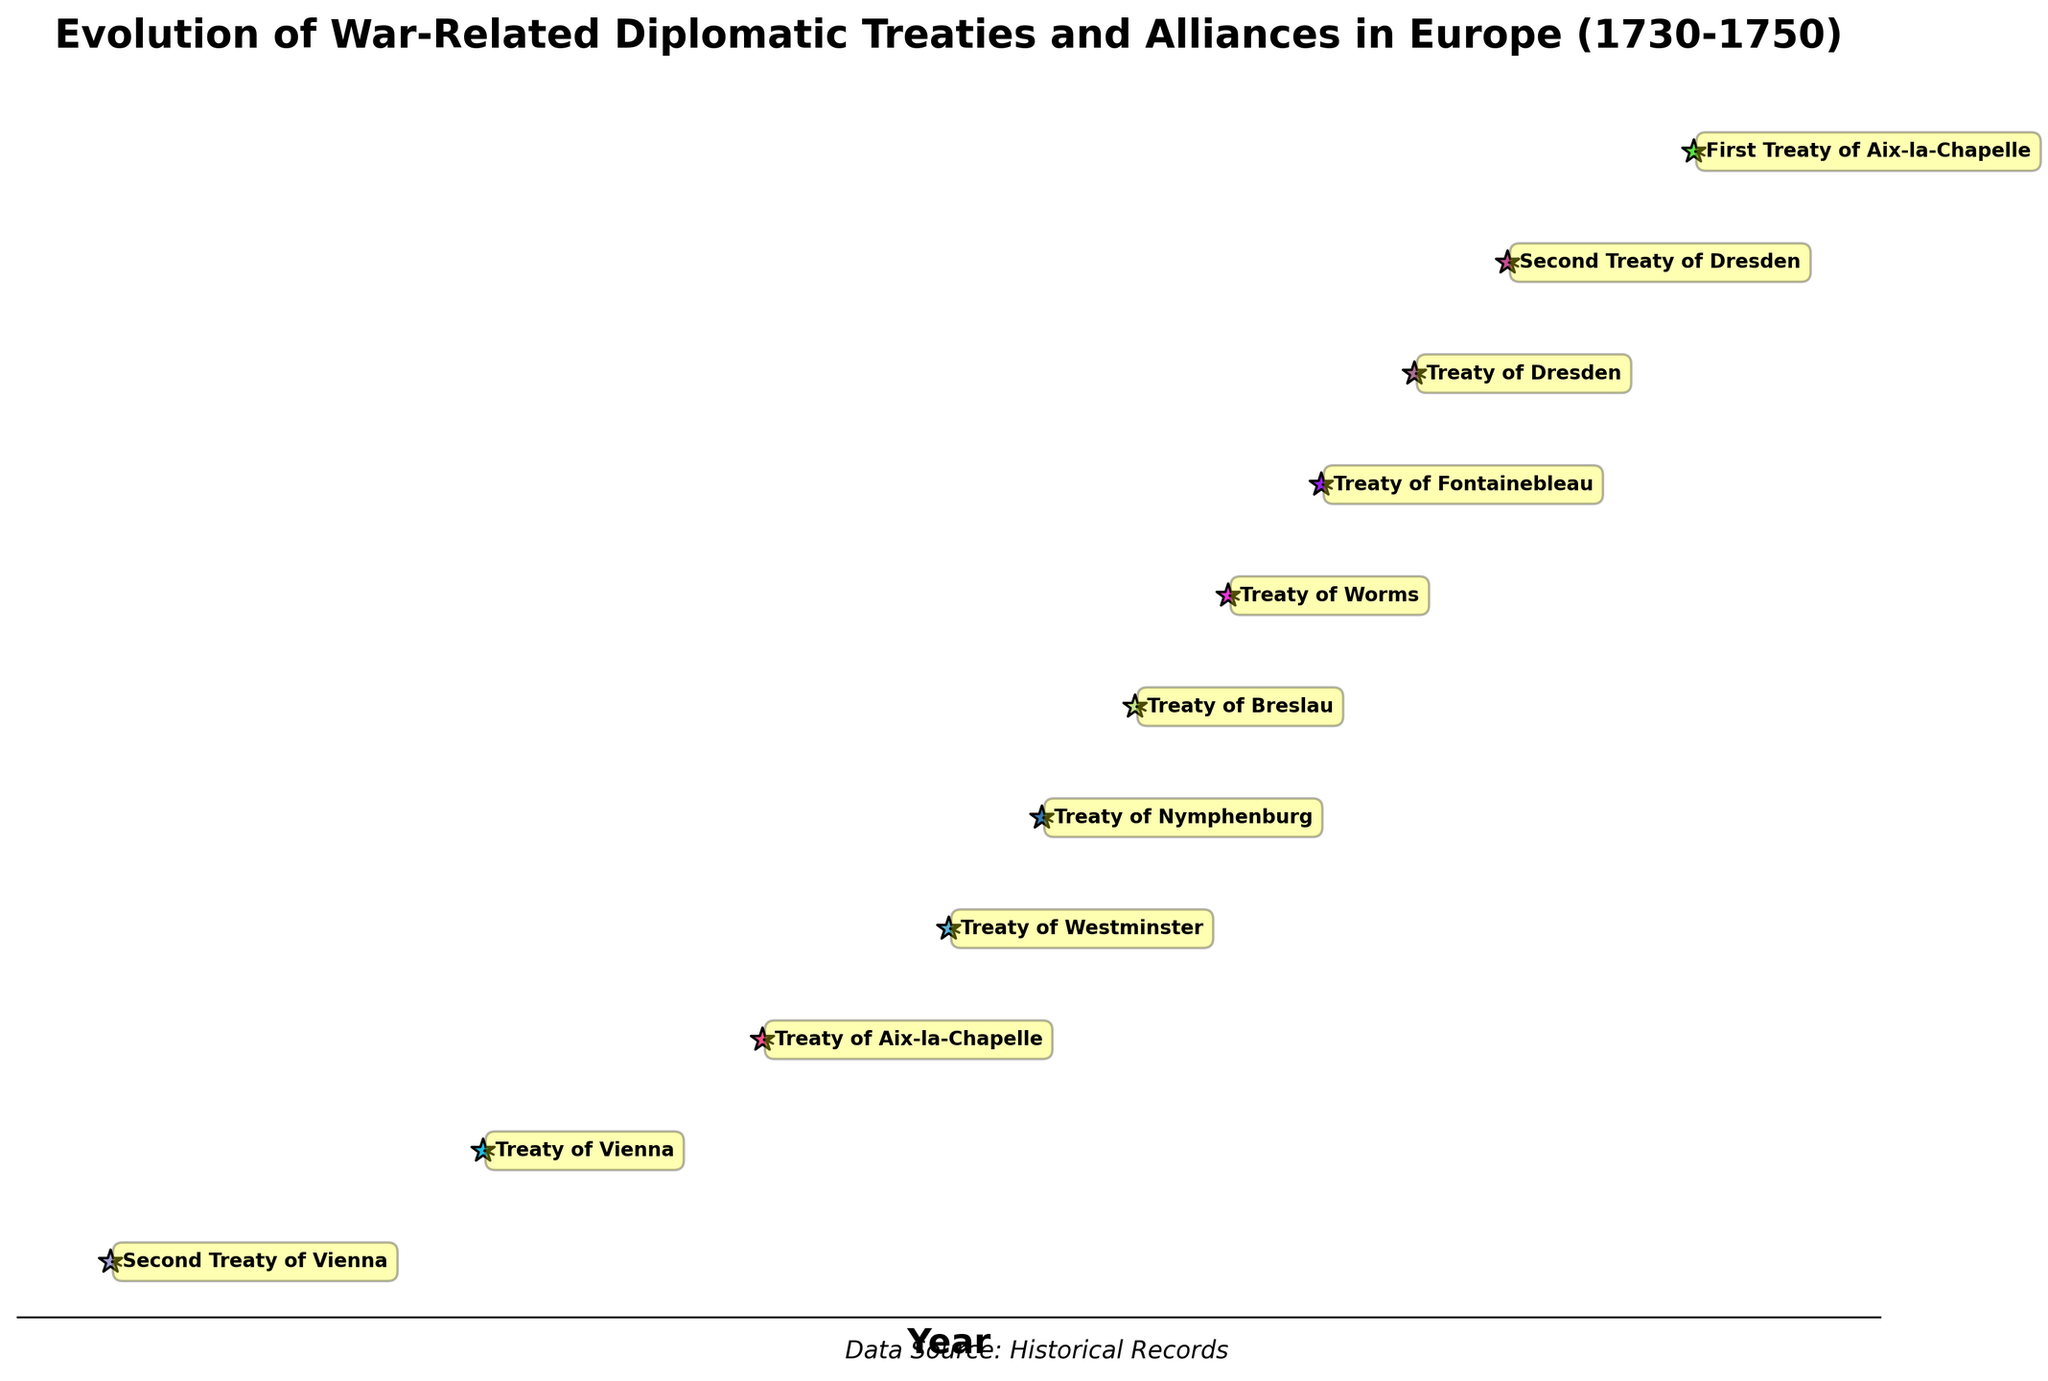What is the title of the figure? The title is usually found at the top of the figure. Look at the large bold text above the plot area.
Answer: Evolution of War-Related Diplomatic Treaties and Alliances in Europe (1730-1750) How many treaties/alliances are shown in the figure? Count the number of star markers on the plot, each representing a treaty or alliance.
Answer: 11 Which treaty occurred in 1740? Find the point corresponding to the year 1740 and read the annotation linked to it.
Answer: Treaty of Westminster Which treaty or alliance involves the most countries? Look at each annotated treaty and count the number of involved parties to find the one with the highest number.
Answer: First Treaty of Aix-la-Chapelle How many treaties were signed between 1742 and 1748, inclusive? Identify and count all treaties with years between 1742 and 1748 on the x-axis.
Answer: 5 What are the involved parties of the Treaty of Worms? Locate the annotation for the Treaty of Worms and read the text describing the involved countries.
Answer: Austria, Great Britain, Sardinia Which year had the most treaties signed? Check the distribution of stars along the x-axis to find any year with more than one treaty.
Answer: Dresden (1945 and 1746) Did the Second Treaty of Vienna occur before or after the Treaty of Aix-la-Chapelle? Compare the positions of the two markers and annotations along the x-axis (1731 vs. 1748).
Answer: Before Are there more treaties involving Austria or Prussia? Count the number of annotations mentioning Austria and those mentioning Prussia, then compare.
Answer: Austria What is the time span covered by the treaties involving Great Britain? Identify the years of treaties involving Great Britain and measure the difference between the earliest and latest year.
Answer: 1731-1748 